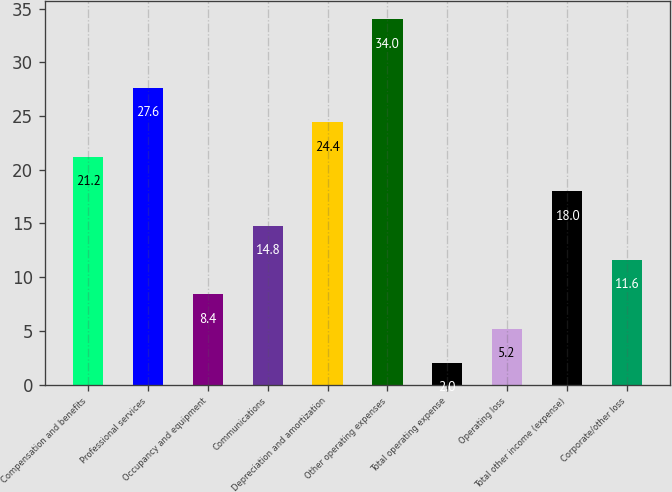Convert chart to OTSL. <chart><loc_0><loc_0><loc_500><loc_500><bar_chart><fcel>Compensation and benefits<fcel>Professional services<fcel>Occupancy and equipment<fcel>Communications<fcel>Depreciation and amortization<fcel>Other operating expenses<fcel>Total operating expense<fcel>Operating loss<fcel>Total other income (expense)<fcel>Corporate/other loss<nl><fcel>21.2<fcel>27.6<fcel>8.4<fcel>14.8<fcel>24.4<fcel>34<fcel>2<fcel>5.2<fcel>18<fcel>11.6<nl></chart> 